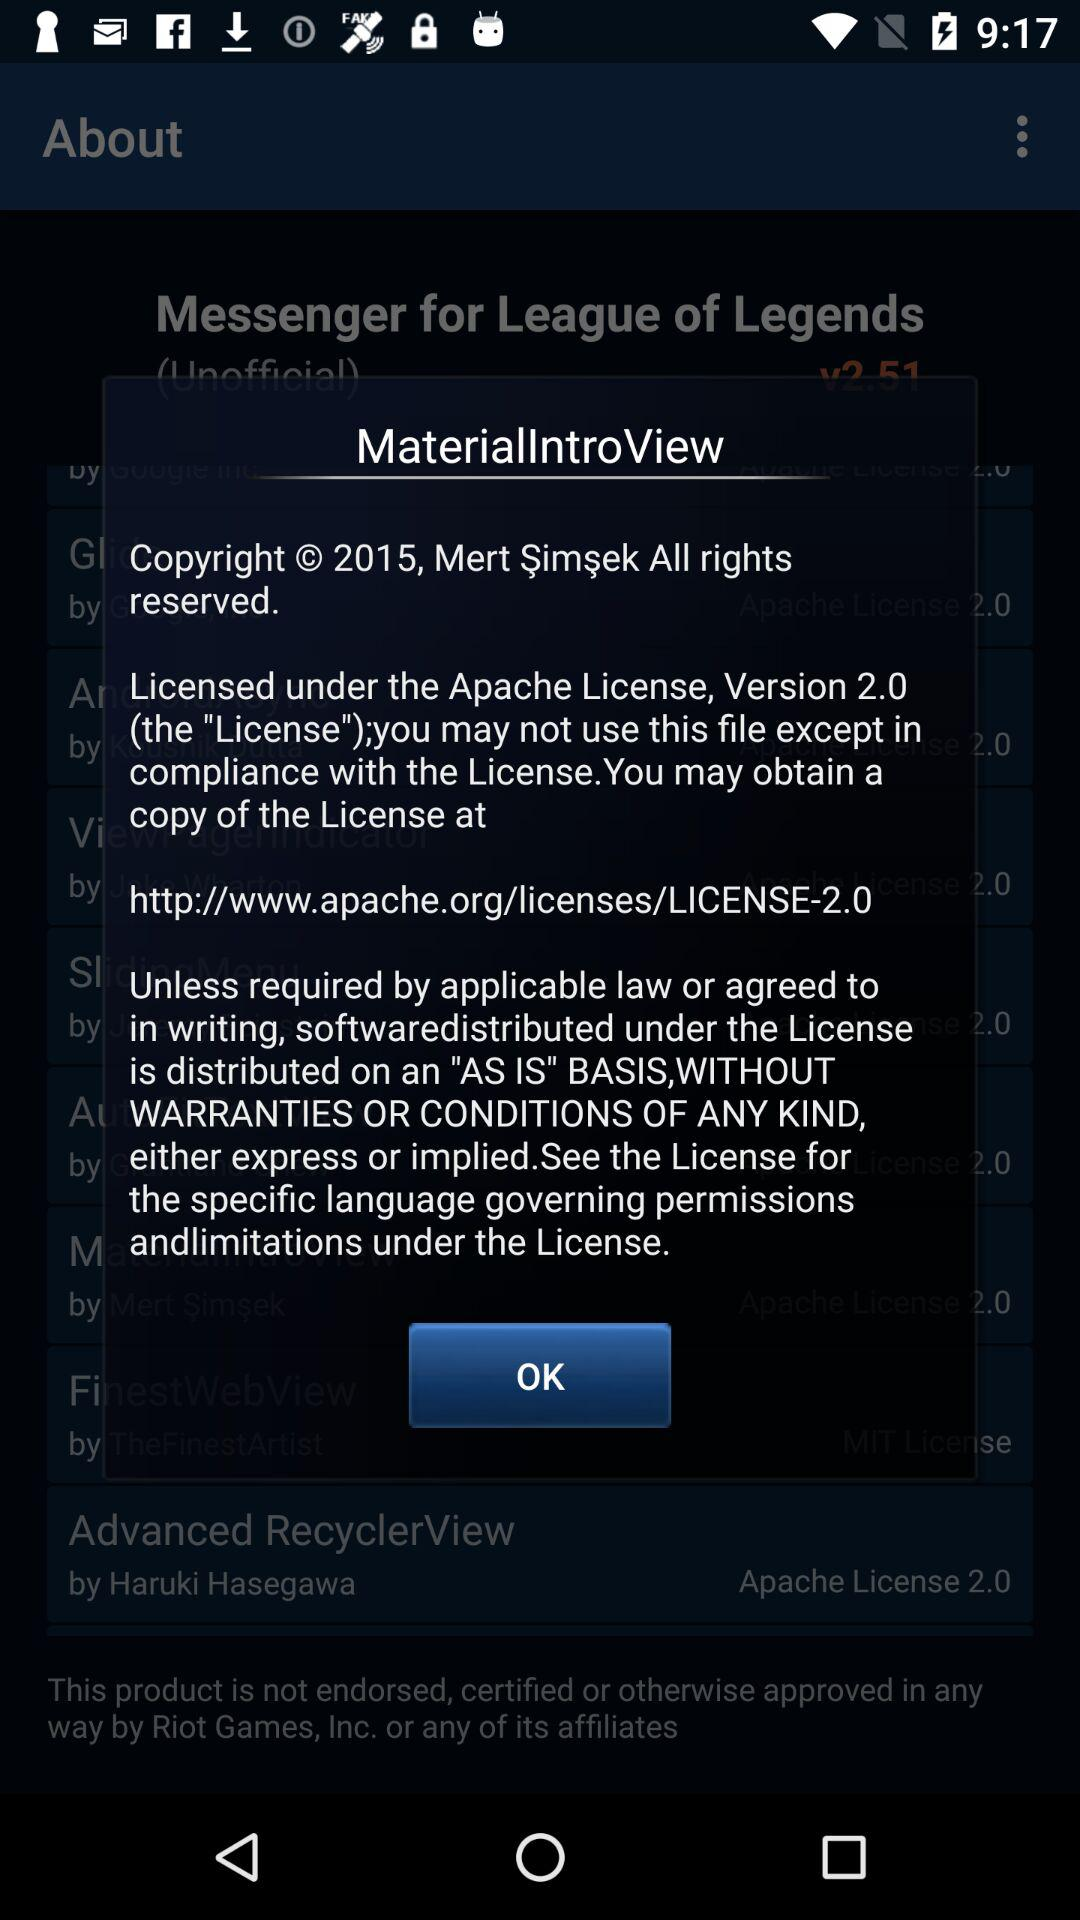What is the year of copyright of the application? The year of copyright of the application is 2015. 